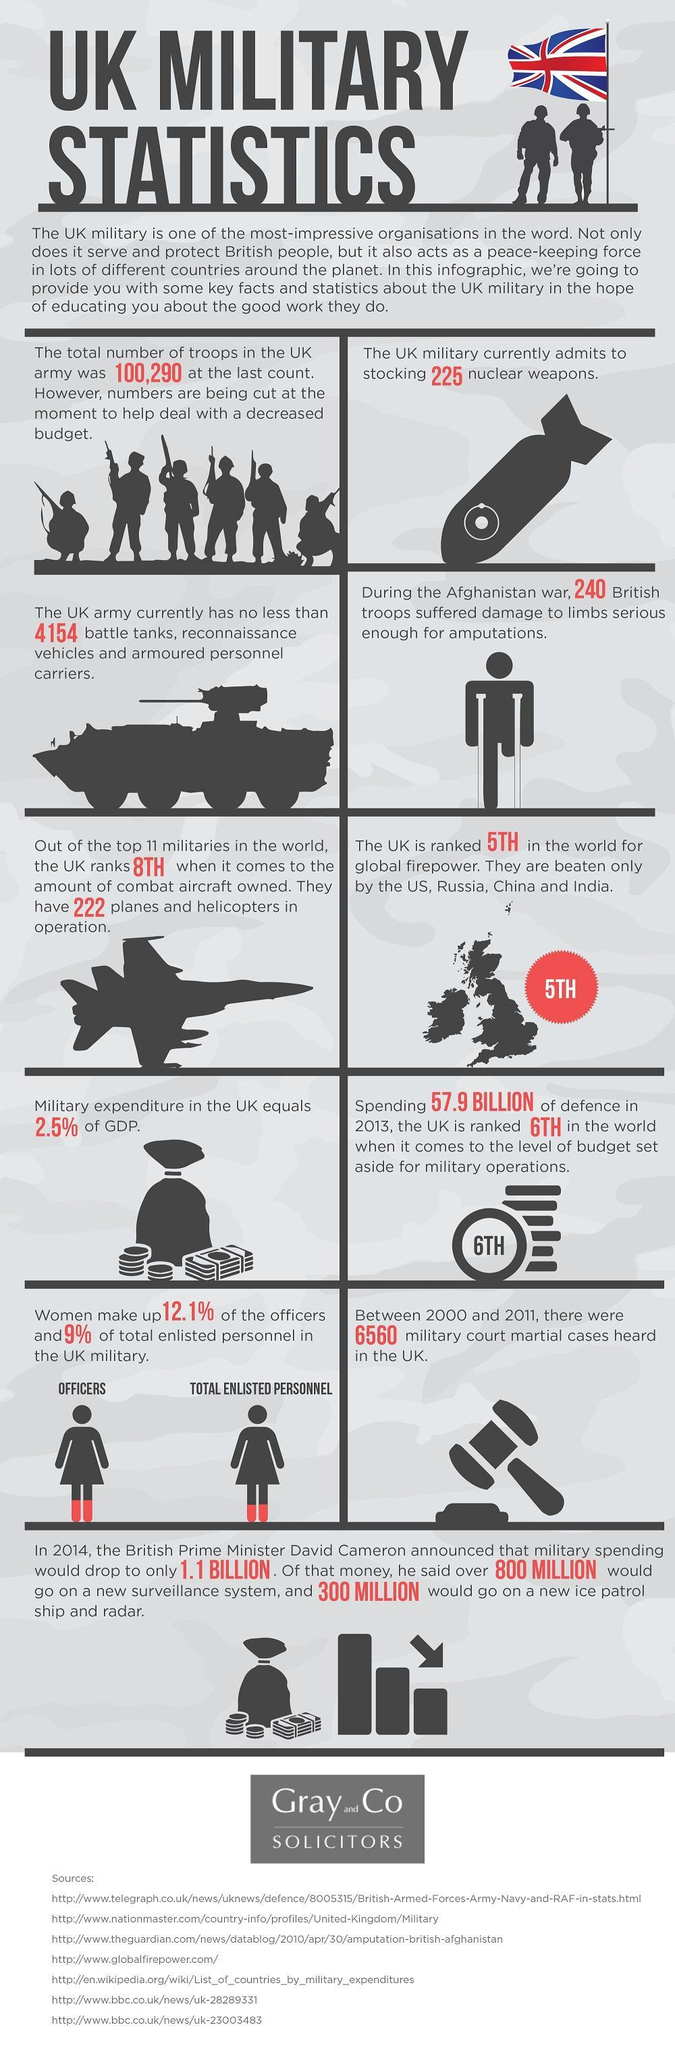How many sources are listed?
Answer the question with a short phrase. 7 